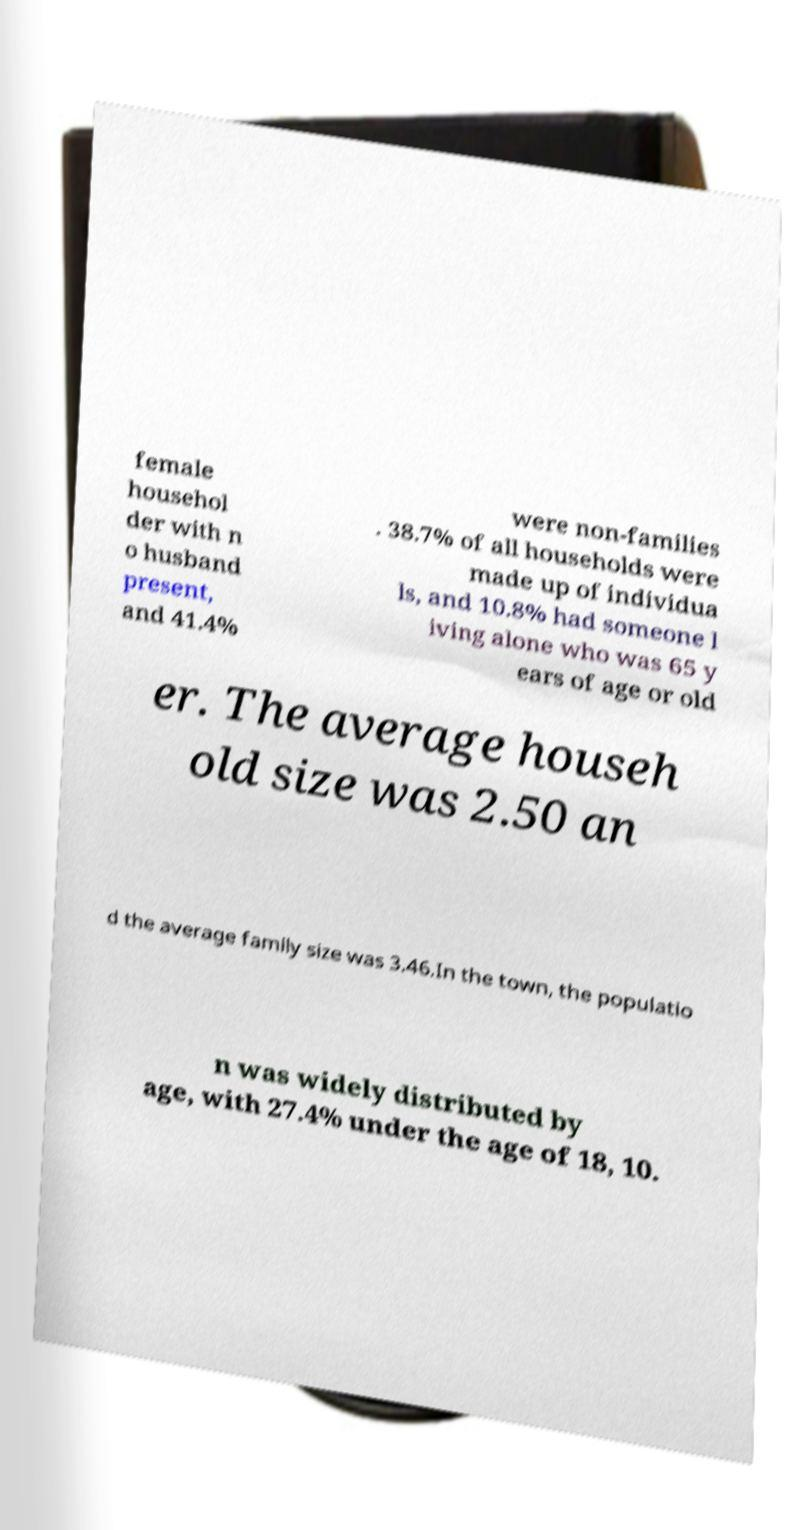Could you extract and type out the text from this image? female househol der with n o husband present, and 41.4% were non-families . 38.7% of all households were made up of individua ls, and 10.8% had someone l iving alone who was 65 y ears of age or old er. The average househ old size was 2.50 an d the average family size was 3.46.In the town, the populatio n was widely distributed by age, with 27.4% under the age of 18, 10. 